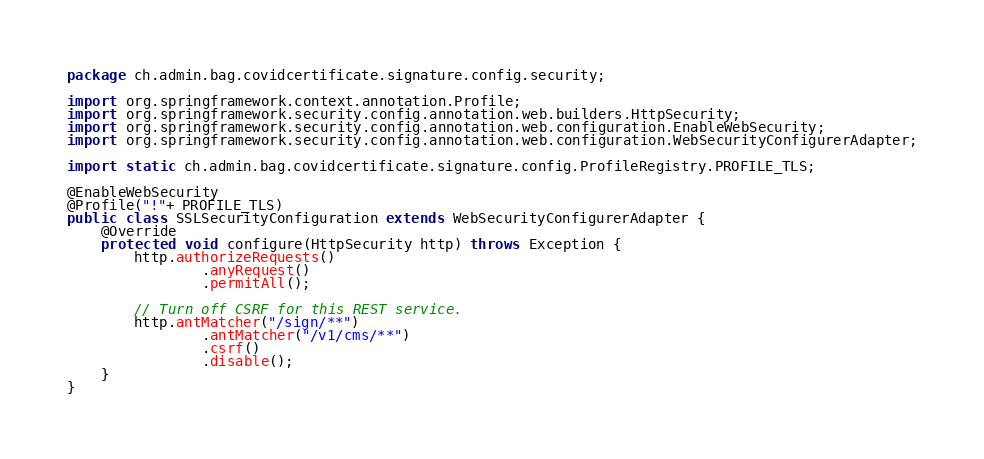<code> <loc_0><loc_0><loc_500><loc_500><_Java_>package ch.admin.bag.covidcertificate.signature.config.security;

import org.springframework.context.annotation.Profile;
import org.springframework.security.config.annotation.web.builders.HttpSecurity;
import org.springframework.security.config.annotation.web.configuration.EnableWebSecurity;
import org.springframework.security.config.annotation.web.configuration.WebSecurityConfigurerAdapter;

import static ch.admin.bag.covidcertificate.signature.config.ProfileRegistry.PROFILE_TLS;

@EnableWebSecurity
@Profile("!"+ PROFILE_TLS)
public class SSLSecurityConfiguration extends WebSecurityConfigurerAdapter {
    @Override
    protected void configure(HttpSecurity http) throws Exception {
        http.authorizeRequests()
                .anyRequest()
                .permitAll();

        // Turn off CSRF for this REST service.
        http.antMatcher("/sign/**")
                .antMatcher("/v1/cms/**")
                .csrf()
                .disable();
    }
}</code> 